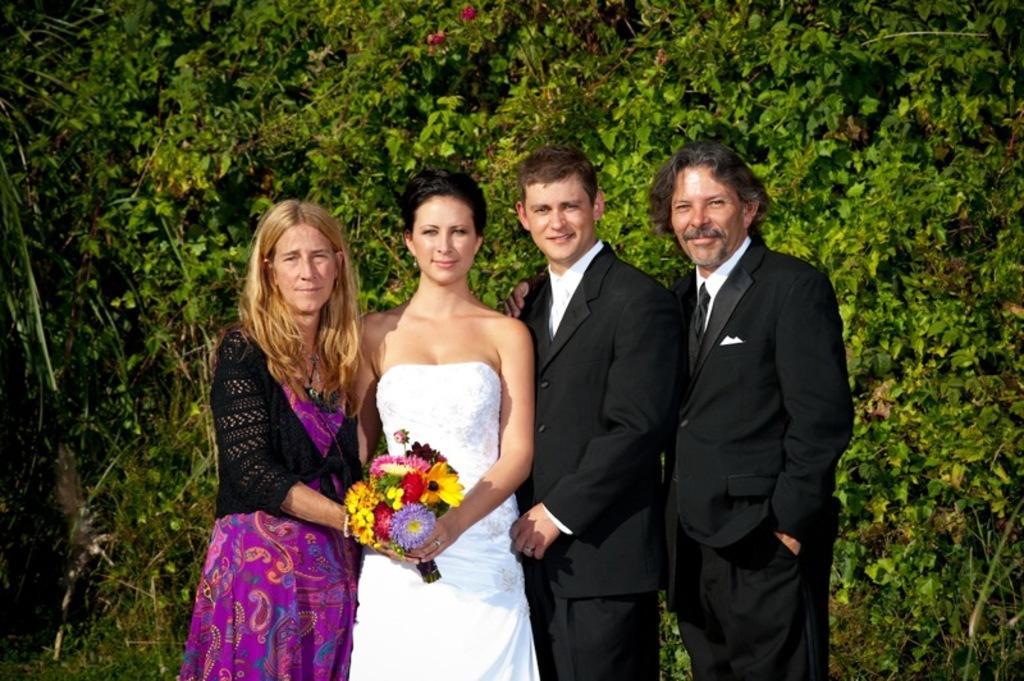Can you describe this image briefly? In this image, we can see four people are standing and smiling. Here we can see two women are holding a flower bouquet. Background we can see trees, leaves and flowers. 